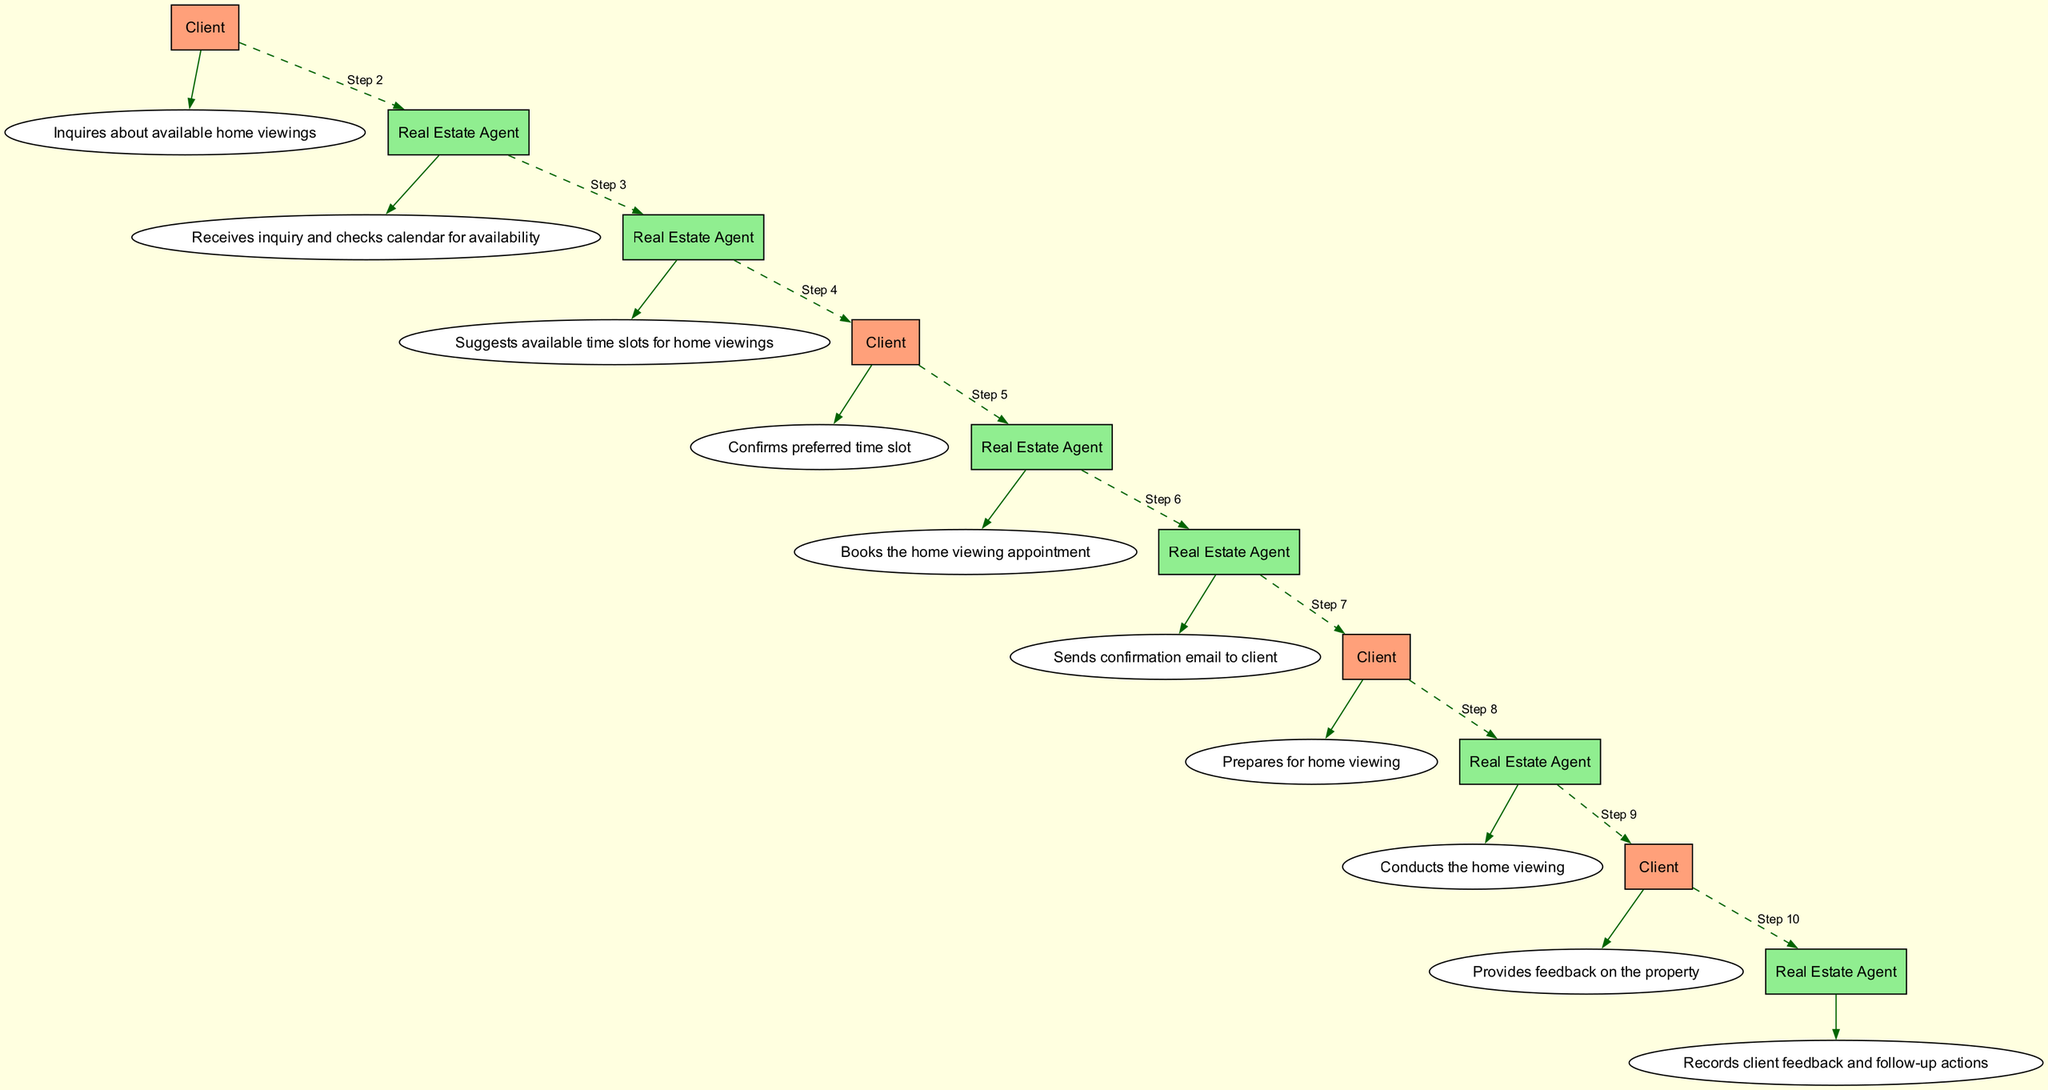What is the first action taken by the Client? The first action taken by the Client is recorded in the sequence diagram as "Inquires about available home viewings." This is the initial step and represents the starting point of the interaction process.
Answer: Inquires about available home viewings Who checks the calendar for availability? According to the diagram, the Real Estate Agent receives the Client's inquiry and subsequently checks the calendar for availability. This action is depicted immediately following the Client's first action.
Answer: Real Estate Agent How many total actions are in the sequence? To determine the total actions, we can count the items listed in the `sequenceElements` of the diagram. There are ten distinct actions from the Client and Real Estate Agent.
Answer: Ten What step comes after the Client confirms the preferred time slot? After the Client confirms the preferred time slot, as shown in the sequence, the Real Estate Agent books the home viewing appointment. This follows sequentially in the process.
Answer: Books the home viewing appointment What color represents the Real Estate Agent's actions in the diagram? The Real Estate Agent's actions are depicted in light green color in the diagram, as specified in the node attributes for the agent.
Answer: Light green What action involves the Client preparing for home viewing? The action where the Client prepares for the home viewing is explicitly described in the diagram as "Prepares for home viewing." This action is linked to the sequence of events that lead up to the home viewing itself.
Answer: Prepares for home viewing What action does the Real Estate Agent take after conducting the home viewing? Following the home viewing, the Real Estate Agent records the client's feedback and any subsequent follow-up actions. This shows the agent's responsiveness to the client's input.
Answer: Records client feedback and follow-up actions How many interactions are initiated by the Client? The Client initiates a total of four distinct interactions within the sequence: inquiring about viewings, confirming the time slot, preparing for the viewing, and providing feedback. Thus, the result counts all client-specified actions in the sequence.
Answer: Four What is the last action in the sequence? The final action in the sequence diagram is that the Real Estate Agent records client feedback and follow-up actions, concluding the interaction process depicted in the diagram.
Answer: Records client feedback and follow-up actions 